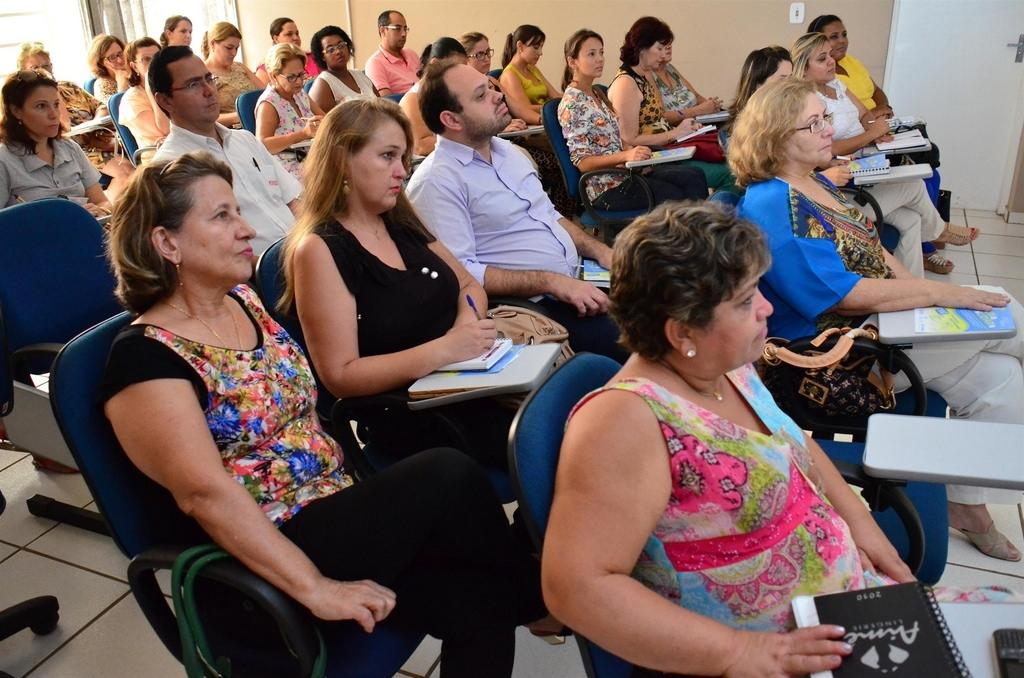How many people are in the image? There are many people in the image. What are the people doing in the image? The people are sitting in chairs. What color are the chairs? The chairs are blue. What is visible beneath the people's feet in the image? There is a floor visible in the image. What can be seen behind the people in the image? There is a wall and a door in the background of the image. What type of guitar can be seen leaning against the wall in the image? There is no guitar present in the image; only people, chairs, a floor, a wall, and a door are visible. 